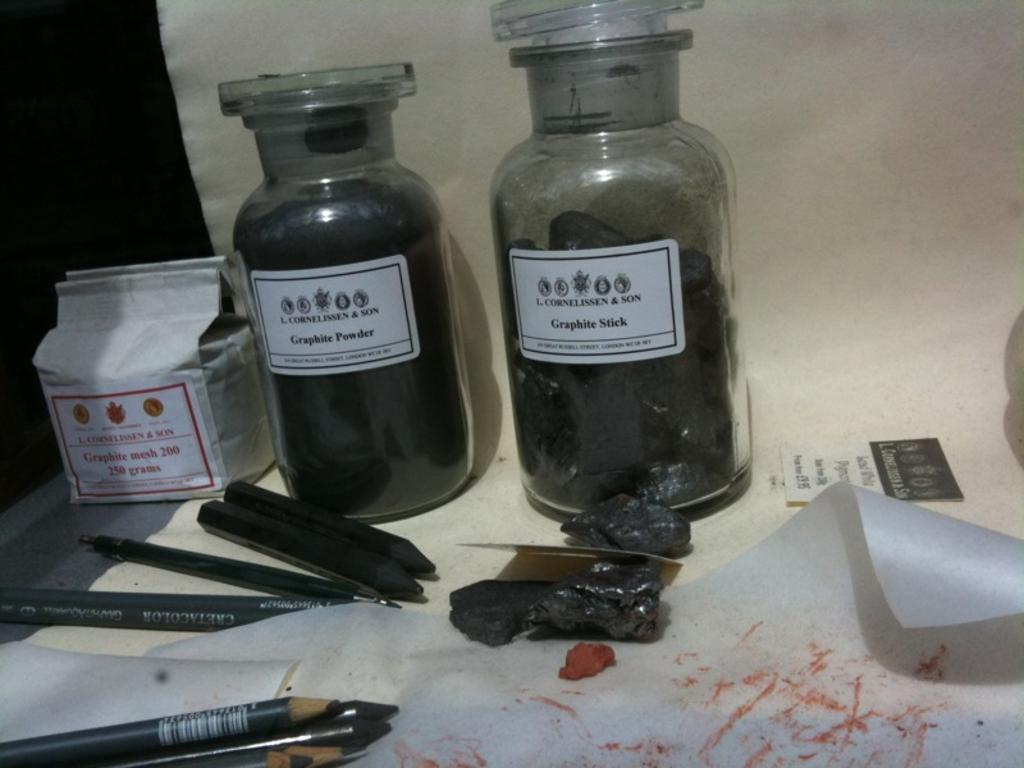How many glass bottles are in the image? There are two glass bottles in the image. What is attached to the bottles? A paper is stuck to the bottles. What writing instruments can be seen in the image? There are pencils visible in the image. Where is the paper located in the image? There is a paper on the left side of the image. What type of alarm can be heard going off in the image? There is no alarm present in the image, so it cannot be heard or seen. 